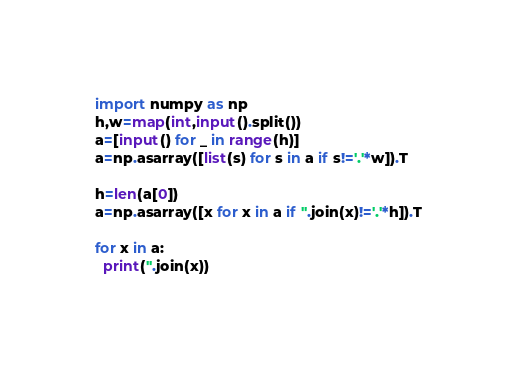<code> <loc_0><loc_0><loc_500><loc_500><_Python_>import numpy as np
h,w=map(int,input().split())
a=[input() for _ in range(h)]
a=np.asarray([list(s) for s in a if s!='.'*w]).T

h=len(a[0])
a=np.asarray([x for x in a if ''.join(x)!='.'*h]).T

for x in a:
  print(''.join(x))</code> 